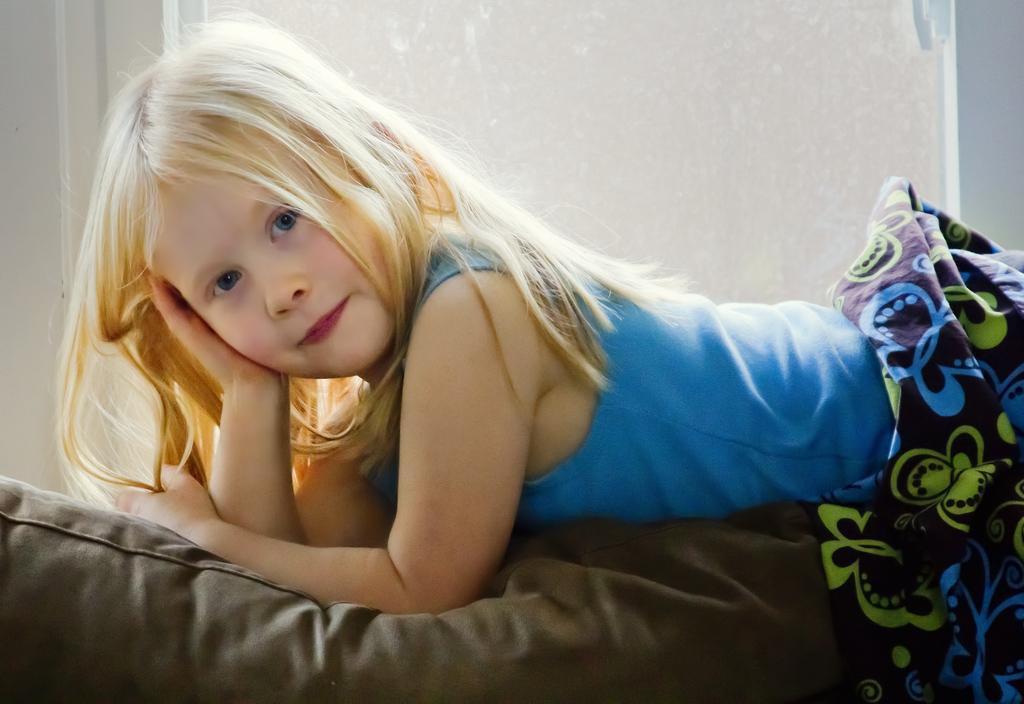In one or two sentences, can you explain what this image depicts? In this image we can see a child on the bed and we can see a cloth. At the back we can see the wall. 